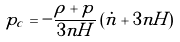Convert formula to latex. <formula><loc_0><loc_0><loc_500><loc_500>p _ { c } = - \frac { \rho + p } { 3 n H } \left ( { \dot { n } + 3 n H } \right )</formula> 